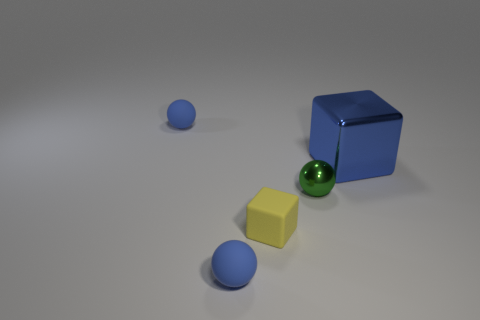Add 2 small balls. How many objects exist? 7 Subtract all spheres. How many objects are left? 2 Add 4 matte cubes. How many matte cubes are left? 5 Add 4 cubes. How many cubes exist? 6 Subtract 1 green balls. How many objects are left? 4 Subtract all tiny green balls. Subtract all tiny red cylinders. How many objects are left? 4 